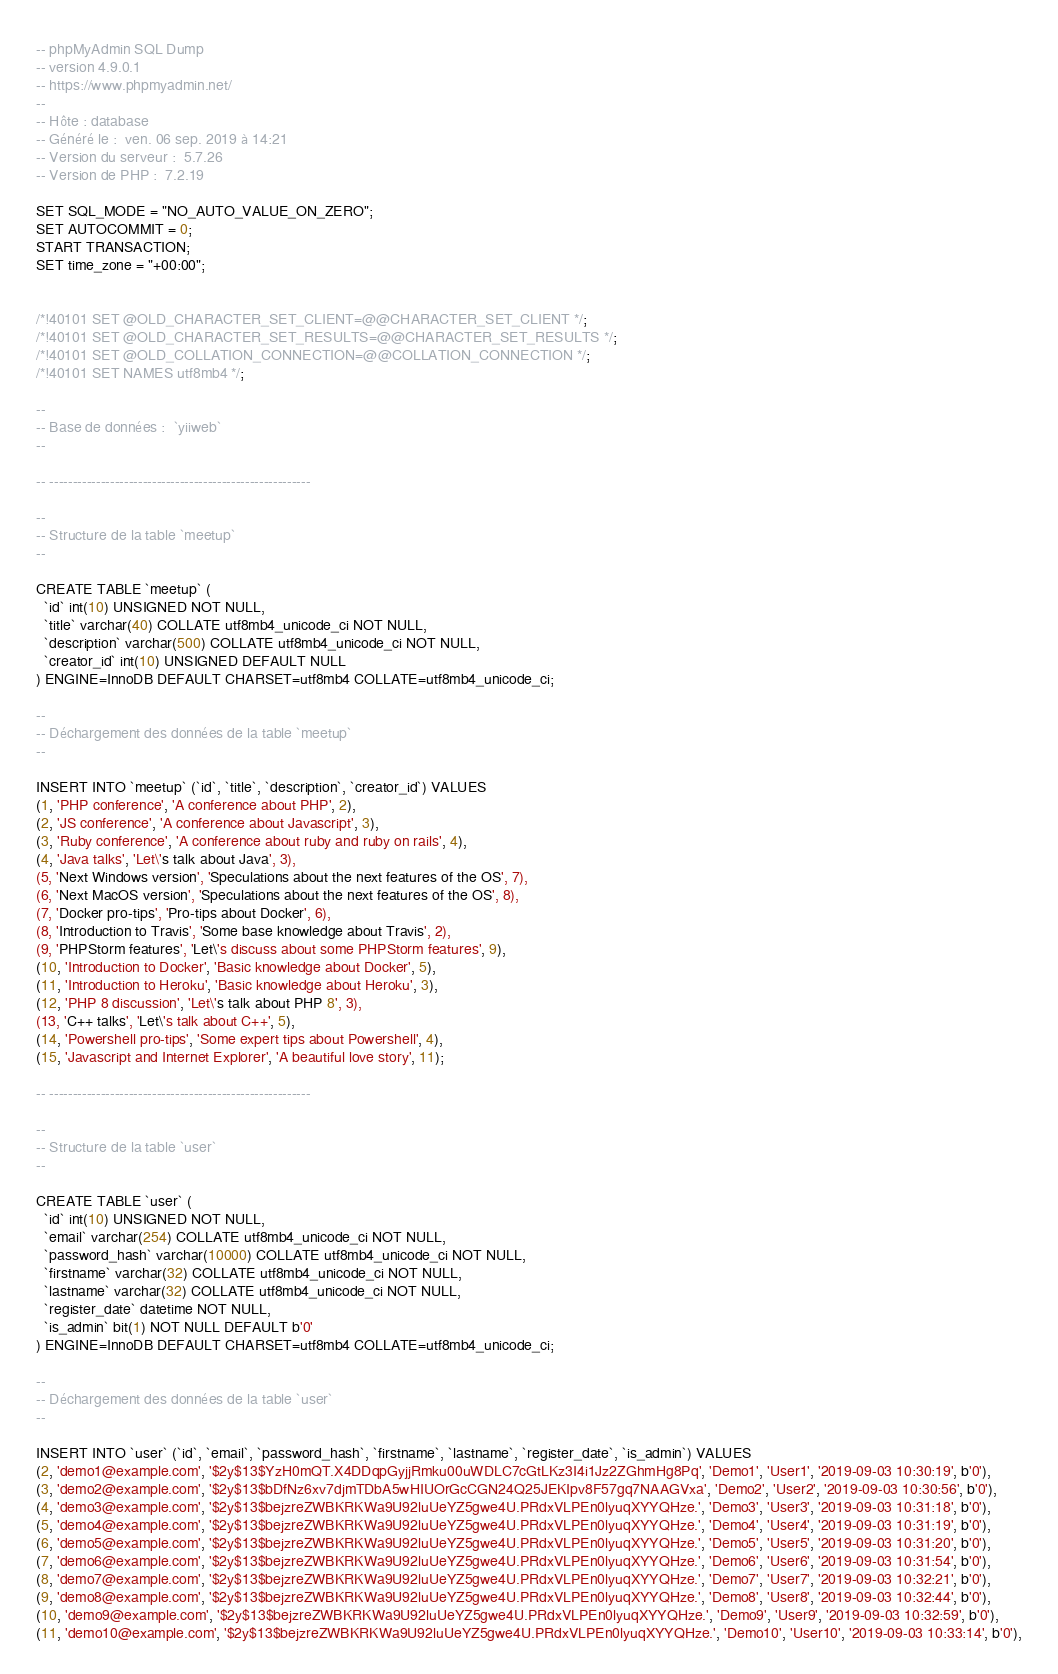Convert code to text. <code><loc_0><loc_0><loc_500><loc_500><_SQL_>-- phpMyAdmin SQL Dump
-- version 4.9.0.1
-- https://www.phpmyadmin.net/
--
-- Hôte : database
-- Généré le :  ven. 06 sep. 2019 à 14:21
-- Version du serveur :  5.7.26
-- Version de PHP :  7.2.19

SET SQL_MODE = "NO_AUTO_VALUE_ON_ZERO";
SET AUTOCOMMIT = 0;
START TRANSACTION;
SET time_zone = "+00:00";


/*!40101 SET @OLD_CHARACTER_SET_CLIENT=@@CHARACTER_SET_CLIENT */;
/*!40101 SET @OLD_CHARACTER_SET_RESULTS=@@CHARACTER_SET_RESULTS */;
/*!40101 SET @OLD_COLLATION_CONNECTION=@@COLLATION_CONNECTION */;
/*!40101 SET NAMES utf8mb4 */;

--
-- Base de données :  `yiiweb`
--

-- --------------------------------------------------------

--
-- Structure de la table `meetup`
--

CREATE TABLE `meetup` (
  `id` int(10) UNSIGNED NOT NULL,
  `title` varchar(40) COLLATE utf8mb4_unicode_ci NOT NULL,
  `description` varchar(500) COLLATE utf8mb4_unicode_ci NOT NULL,
  `creator_id` int(10) UNSIGNED DEFAULT NULL
) ENGINE=InnoDB DEFAULT CHARSET=utf8mb4 COLLATE=utf8mb4_unicode_ci;

--
-- Déchargement des données de la table `meetup`
--

INSERT INTO `meetup` (`id`, `title`, `description`, `creator_id`) VALUES
(1, 'PHP conference', 'A conference about PHP', 2),
(2, 'JS conference', 'A conference about Javascript', 3),
(3, 'Ruby conference', 'A conference about ruby and ruby on rails', 4),
(4, 'Java talks', 'Let\'s talk about Java', 3),
(5, 'Next Windows version', 'Speculations about the next features of the OS', 7),
(6, 'Next MacOS version', 'Speculations about the next features of the OS', 8),
(7, 'Docker pro-tips', 'Pro-tips about Docker', 6),
(8, 'Introduction to Travis', 'Some base knowledge about Travis', 2),
(9, 'PHPStorm features', 'Let\'s discuss about some PHPStorm features', 9),
(10, 'Introduction to Docker', 'Basic knowledge about Docker', 5),
(11, 'Introduction to Heroku', 'Basic knowledge about Heroku', 3),
(12, 'PHP 8 discussion', 'Let\'s talk about PHP 8', 3),
(13, 'C++ talks', 'Let\'s talk about C++', 5),
(14, 'Powershell pro-tips', 'Some expert tips about Powershell', 4),
(15, 'Javascript and Internet Explorer', 'A beautiful love story', 11);

-- --------------------------------------------------------

--
-- Structure de la table `user`
--

CREATE TABLE `user` (
  `id` int(10) UNSIGNED NOT NULL,
  `email` varchar(254) COLLATE utf8mb4_unicode_ci NOT NULL,
  `password_hash` varchar(10000) COLLATE utf8mb4_unicode_ci NOT NULL,
  `firstname` varchar(32) COLLATE utf8mb4_unicode_ci NOT NULL,
  `lastname` varchar(32) COLLATE utf8mb4_unicode_ci NOT NULL,
  `register_date` datetime NOT NULL,
  `is_admin` bit(1) NOT NULL DEFAULT b'0'
) ENGINE=InnoDB DEFAULT CHARSET=utf8mb4 COLLATE=utf8mb4_unicode_ci;

--
-- Déchargement des données de la table `user`
--

INSERT INTO `user` (`id`, `email`, `password_hash`, `firstname`, `lastname`, `register_date`, `is_admin`) VALUES
(2, 'demo1@example.com', '$2y$13$YzH0mQT.X4DDqpGyjjRmku00uWDLC7cGtLKz3I4i1Jz2ZGhmHg8Pq', 'Demo1', 'User1', '2019-09-03 10:30:19', b'0'),
(3, 'demo2@example.com', '$2y$13$bDfNz6xv7djmTDbA5wHIUOrGcCGN24Q25JEKIpv8F57gq7NAAGVxa', 'Demo2', 'User2', '2019-09-03 10:30:56', b'0'),
(4, 'demo3@example.com', '$2y$13$bejzreZWBKRKWa9U92luUeYZ5gwe4U.PRdxVLPEn0lyuqXYYQHze.', 'Demo3', 'User3', '2019-09-03 10:31:18', b'0'),
(5, 'demo4@example.com', '$2y$13$bejzreZWBKRKWa9U92luUeYZ5gwe4U.PRdxVLPEn0lyuqXYYQHze.', 'Demo4', 'User4', '2019-09-03 10:31:19', b'0'),
(6, 'demo5@example.com', '$2y$13$bejzreZWBKRKWa9U92luUeYZ5gwe4U.PRdxVLPEn0lyuqXYYQHze.', 'Demo5', 'User5', '2019-09-03 10:31:20', b'0'),
(7, 'demo6@example.com', '$2y$13$bejzreZWBKRKWa9U92luUeYZ5gwe4U.PRdxVLPEn0lyuqXYYQHze.', 'Demo6', 'User6', '2019-09-03 10:31:54', b'0'),
(8, 'demo7@example.com', '$2y$13$bejzreZWBKRKWa9U92luUeYZ5gwe4U.PRdxVLPEn0lyuqXYYQHze.', 'Demo7', 'User7', '2019-09-03 10:32:21', b'0'),
(9, 'demo8@example.com', '$2y$13$bejzreZWBKRKWa9U92luUeYZ5gwe4U.PRdxVLPEn0lyuqXYYQHze.', 'Demo8', 'User8', '2019-09-03 10:32:44', b'0'),
(10, 'demo9@example.com', '$2y$13$bejzreZWBKRKWa9U92luUeYZ5gwe4U.PRdxVLPEn0lyuqXYYQHze.', 'Demo9', 'User9', '2019-09-03 10:32:59', b'0'),
(11, 'demo10@example.com', '$2y$13$bejzreZWBKRKWa9U92luUeYZ5gwe4U.PRdxVLPEn0lyuqXYYQHze.', 'Demo10', 'User10', '2019-09-03 10:33:14', b'0'),</code> 